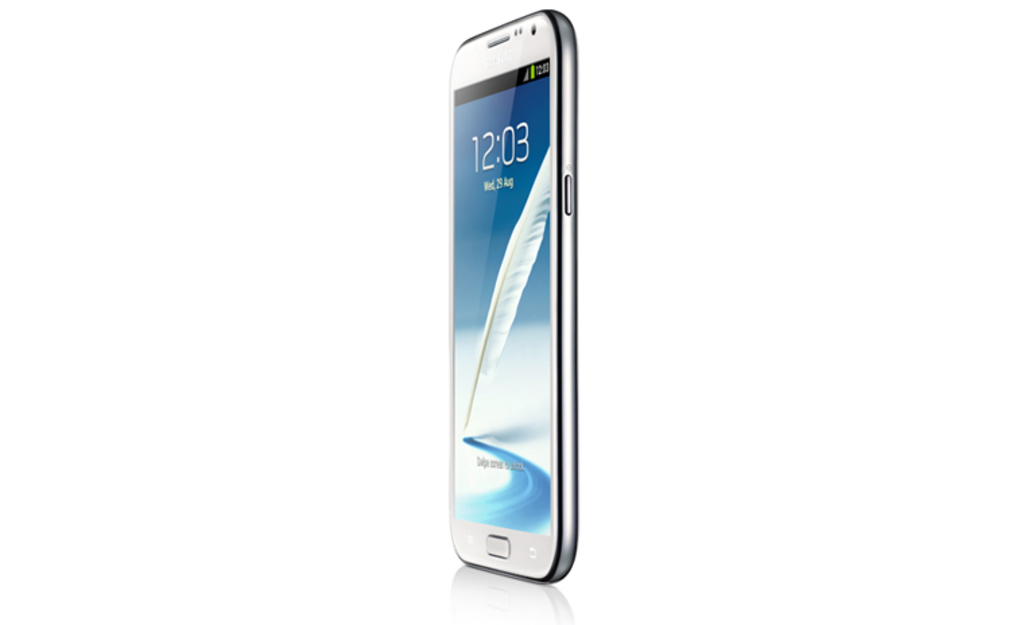What are some of the notable features visible on this phone? The phone features a large, high-resolution display with vibrant colors, minimal side bezels, and a curved edge design, enhancing the visual appeal and ergonomic grip. Can you tell what kind of operating system it might be using based on the image? Based on the interface style displayed on the screen, such as the font and icons, it appears to be running an Android operating system. 